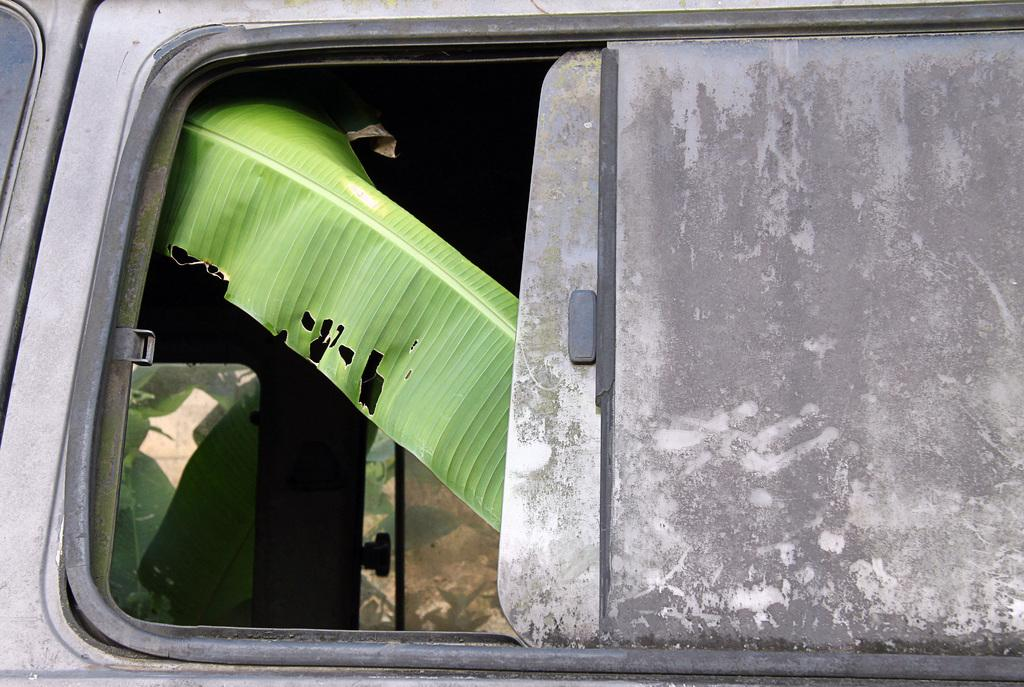What is the main subject of the image? The main subject of the image is a door of a vehicle. What can be seen through the door? Leaves are visible through the door. What type of mine can be seen in the image? There is no mine present in the image; it features a door of a vehicle with leaves visible through it. Is there a crook in the image? There is no crook present in the image. 